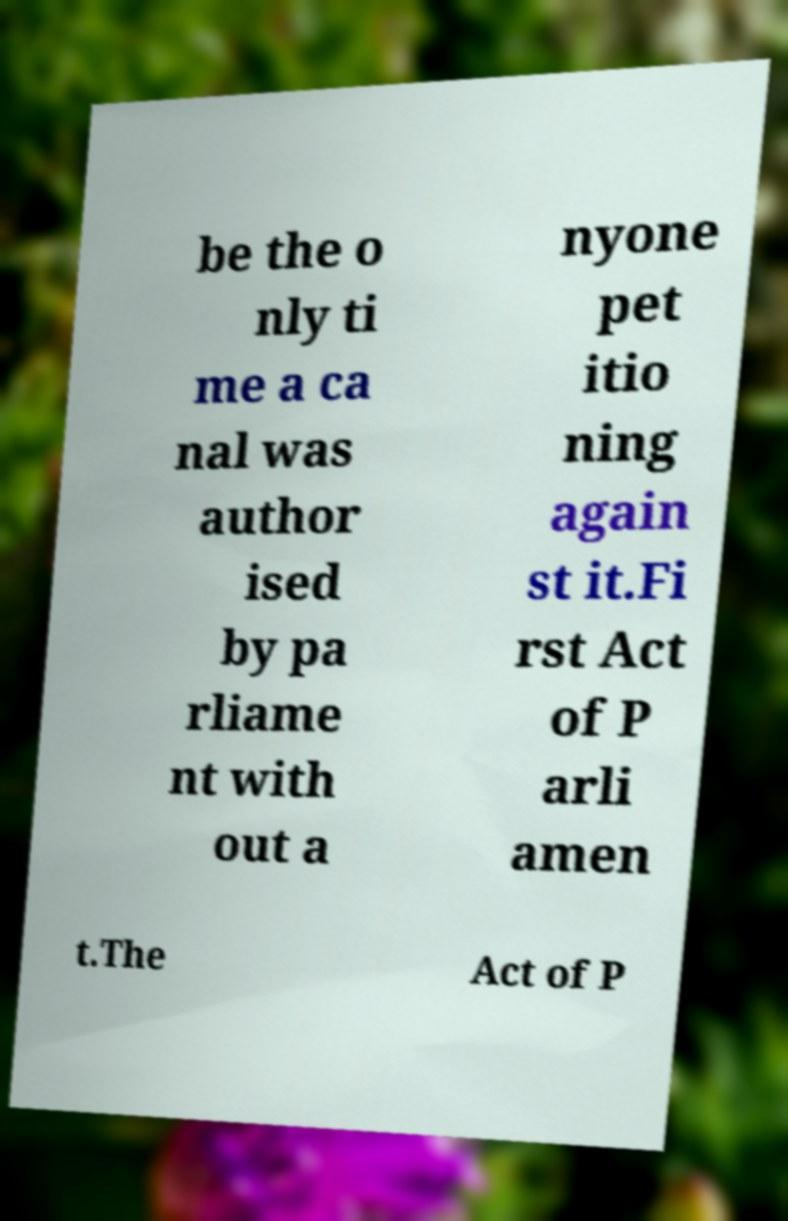I need the written content from this picture converted into text. Can you do that? be the o nly ti me a ca nal was author ised by pa rliame nt with out a nyone pet itio ning again st it.Fi rst Act of P arli amen t.The Act of P 